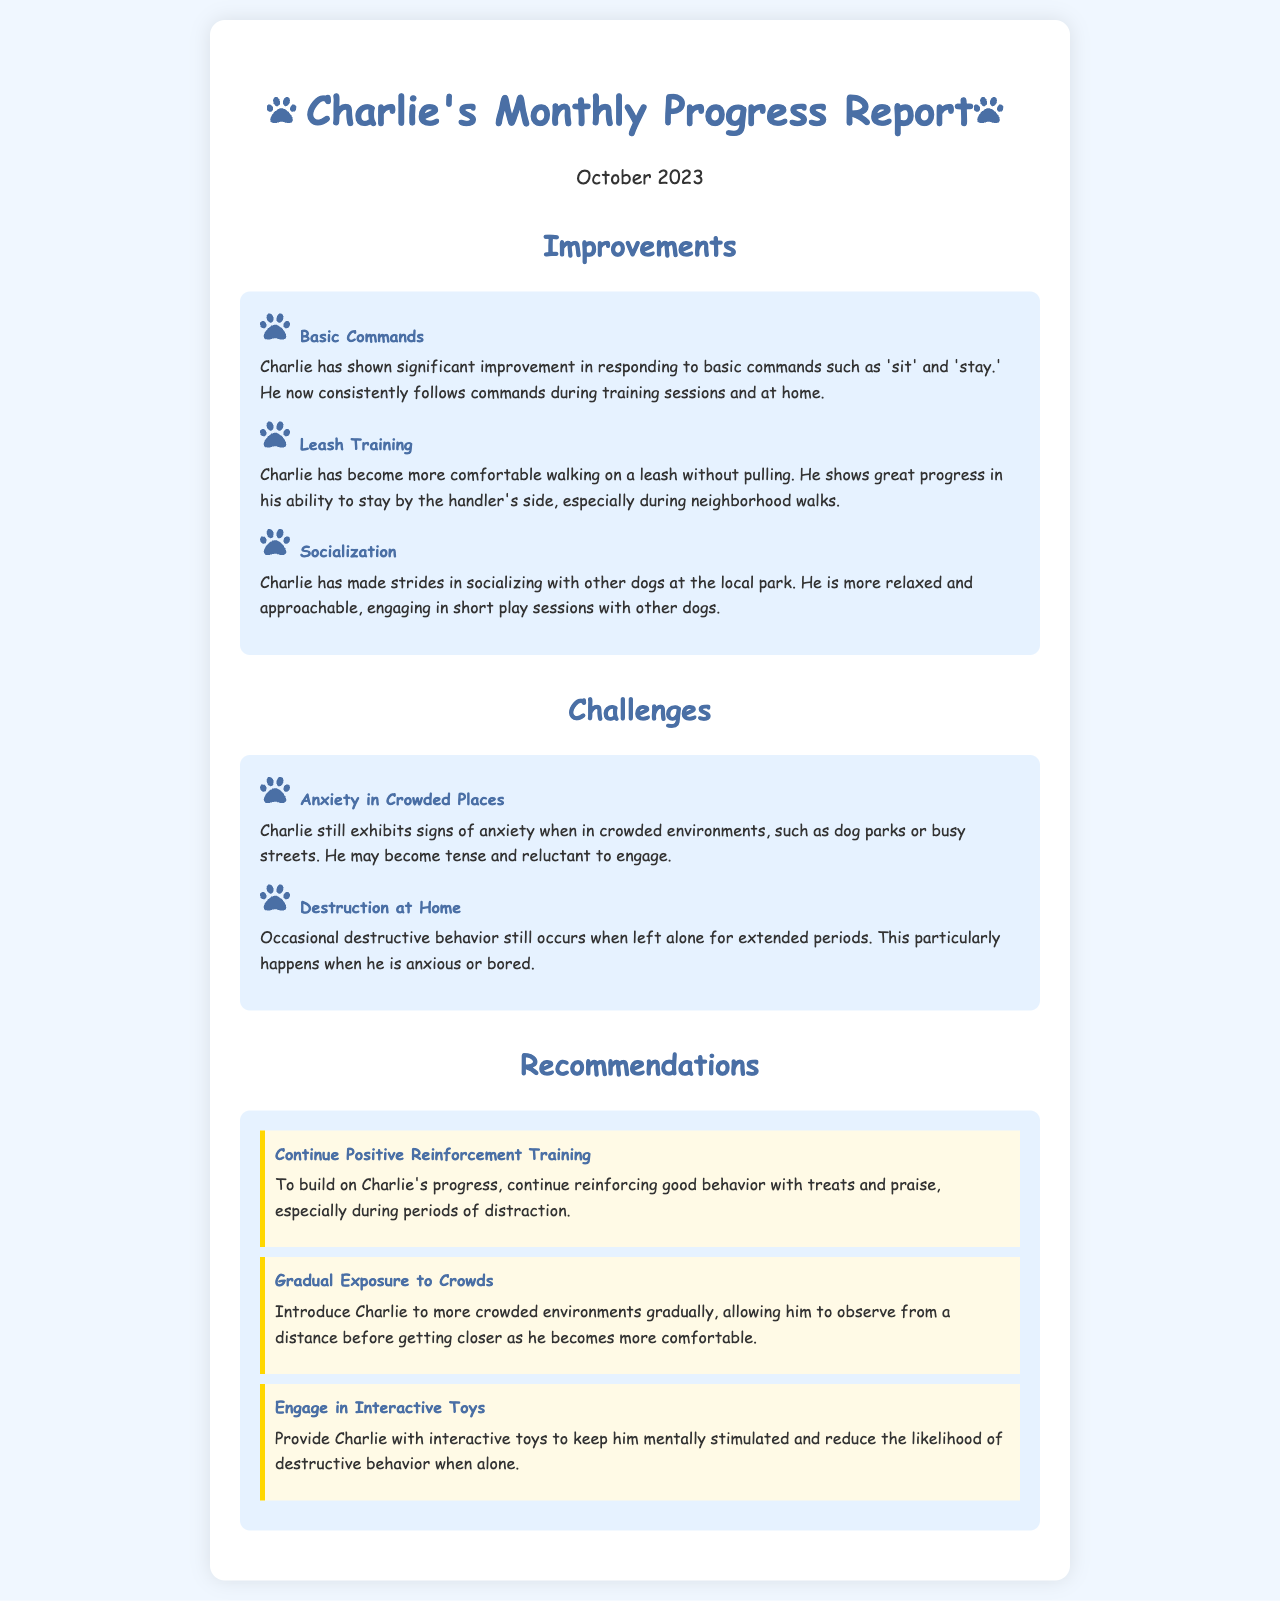What are Charlie's notable improvements? The improvements mentioned in the document are in basic commands, leash training, and socialization.
Answer: Basic commands, leash training, socialization What command does Charlie consistently follow? The document states that Charlie consistently follows the commands 'sit' and 'stay.'
Answer: 'sit' and 'stay' What anxiety-related challenge does Charlie face? The document highlights that Charlie exhibits signs of anxiety in crowded environments, such as dog parks or busy streets.
Answer: Anxiety in crowded places What is one way to reduce Charlie's destructive behavior? The recommendations suggest providing Charlie with interactive toys to keep him mentally stimulated.
Answer: Interactive toys What month is the progress report for? The document indicates that the progress report is for October 2023.
Answer: October 2023 How has Charlie's leash behavior changed? The report shows that Charlie has become more comfortable walking on a leash without pulling.
Answer: More comfortable walking on a leash What is the overall tone of the report regarding Charlie's training? The report emphasizes significant improvements while also addressing challenges, indicating a positive tone.
Answer: Positive What type of training is recommended for Charlie? The document recommends continuing positive reinforcement training to build on Charlie's progress.
Answer: Positive reinforcement training 